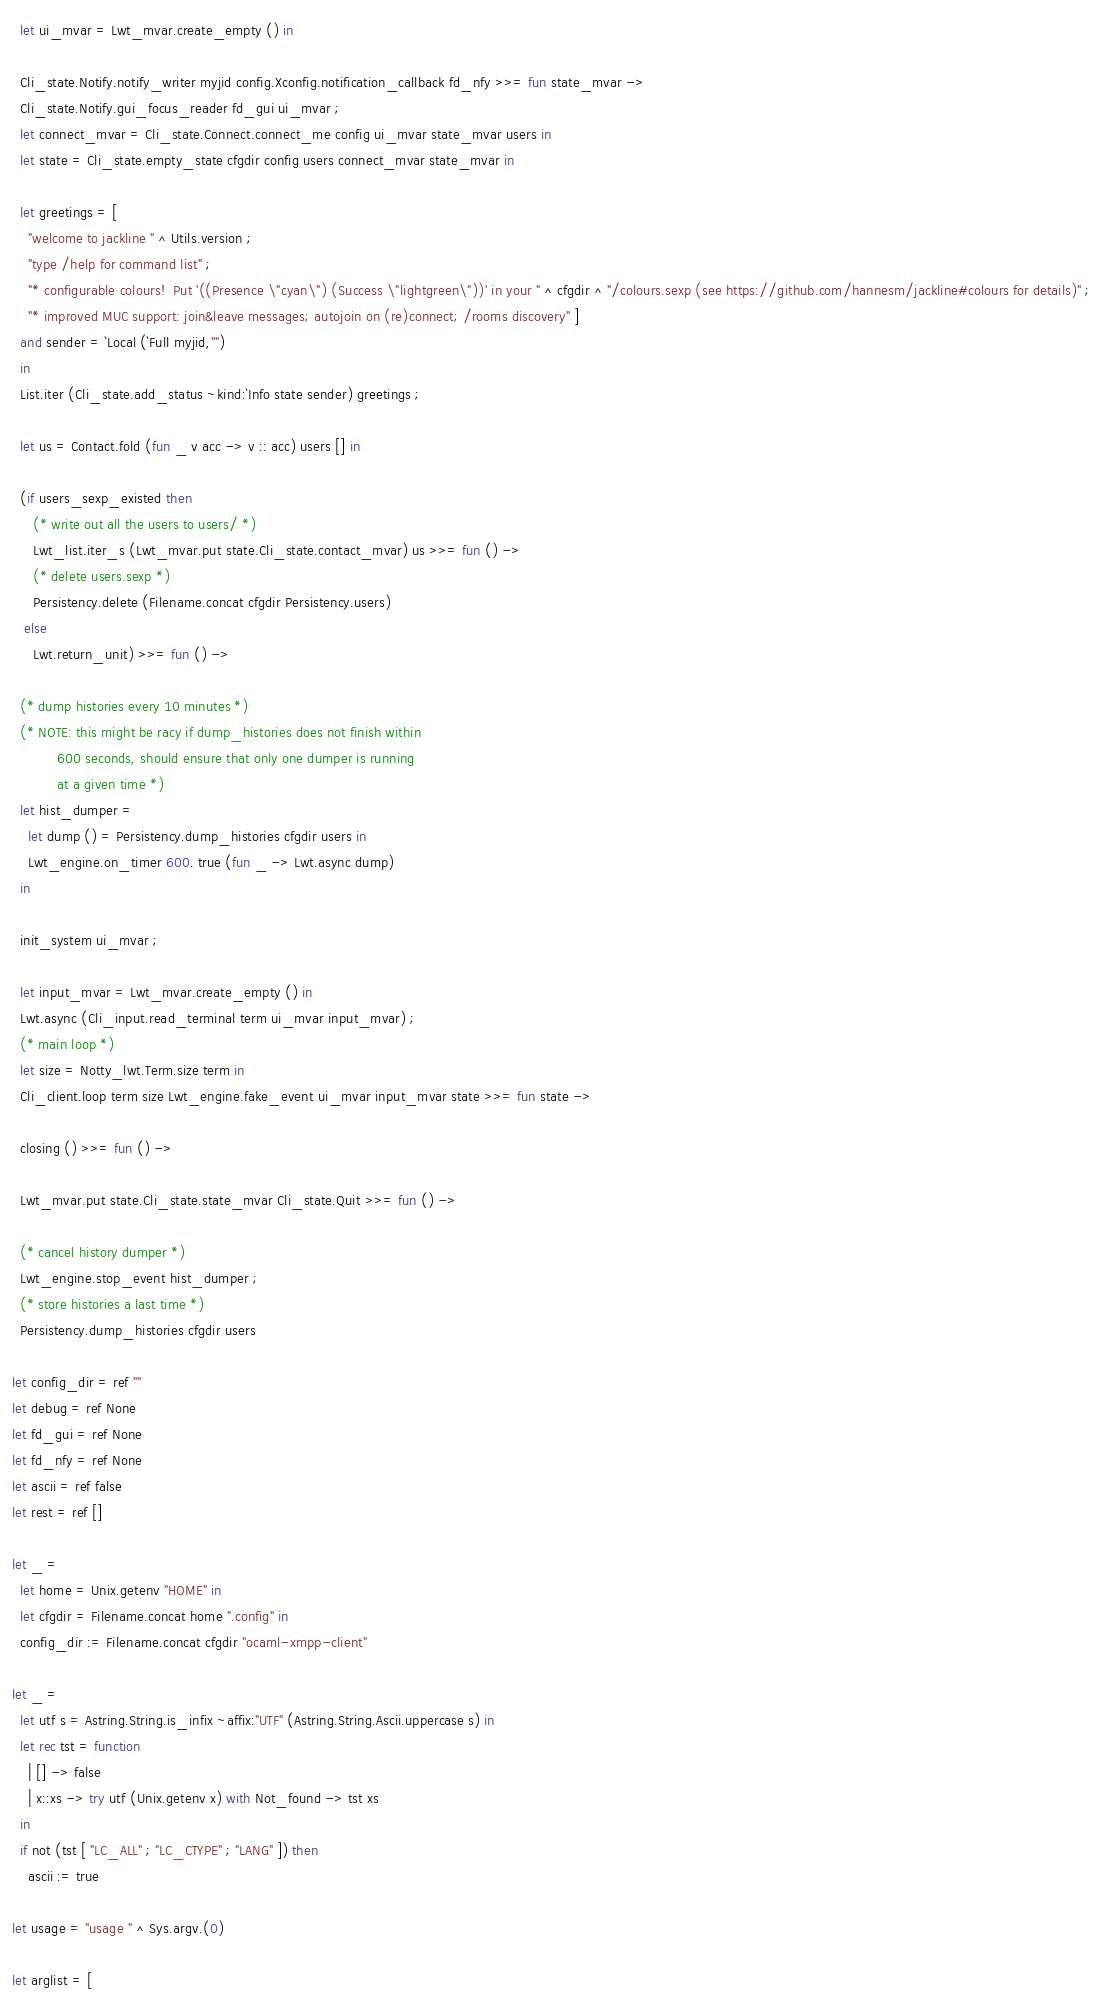<code> <loc_0><loc_0><loc_500><loc_500><_OCaml_>
  let ui_mvar = Lwt_mvar.create_empty () in

  Cli_state.Notify.notify_writer myjid config.Xconfig.notification_callback fd_nfy >>= fun state_mvar ->
  Cli_state.Notify.gui_focus_reader fd_gui ui_mvar ;
  let connect_mvar = Cli_state.Connect.connect_me config ui_mvar state_mvar users in
  let state = Cli_state.empty_state cfgdir config users connect_mvar state_mvar in

  let greetings = [
    "welcome to jackline " ^ Utils.version ;
    "type /help for command list" ;
    "* configurable colours!  Put '((Presence \"cyan\") (Success \"lightgreen\"))' in your " ^ cfgdir ^ "/colours.sexp (see https://github.com/hannesm/jackline#colours for details)" ;
    "* improved MUC support: join&leave messages; autojoin on (re)connect; /rooms discovery" ]
  and sender = `Local (`Full myjid,"")
  in
  List.iter (Cli_state.add_status ~kind:`Info state sender) greetings ;

  let us = Contact.fold (fun _ v acc -> v :: acc) users [] in

  (if users_sexp_existed then
     (* write out all the users to users/ *)
     Lwt_list.iter_s (Lwt_mvar.put state.Cli_state.contact_mvar) us >>= fun () ->
     (* delete users.sexp *)
     Persistency.delete (Filename.concat cfgdir Persistency.users)
   else
     Lwt.return_unit) >>= fun () ->

  (* dump histories every 10 minutes *)
  (* NOTE: this might be racy if dump_histories does not finish within
           600 seconds, should ensure that only one dumper is running
           at a given time *)
  let hist_dumper =
    let dump () = Persistency.dump_histories cfgdir users in
    Lwt_engine.on_timer 600. true (fun _ -> Lwt.async dump)
  in

  init_system ui_mvar ;

  let input_mvar = Lwt_mvar.create_empty () in
  Lwt.async (Cli_input.read_terminal term ui_mvar input_mvar) ;
  (* main loop *)
  let size = Notty_lwt.Term.size term in
  Cli_client.loop term size Lwt_engine.fake_event ui_mvar input_mvar state >>= fun state ->

  closing () >>= fun () ->

  Lwt_mvar.put state.Cli_state.state_mvar Cli_state.Quit >>= fun () ->

  (* cancel history dumper *)
  Lwt_engine.stop_event hist_dumper ;
  (* store histories a last time *)
  Persistency.dump_histories cfgdir users

let config_dir = ref ""
let debug = ref None
let fd_gui = ref None
let fd_nfy = ref None
let ascii = ref false
let rest = ref []

let _ =
  let home = Unix.getenv "HOME" in
  let cfgdir = Filename.concat home ".config" in
  config_dir := Filename.concat cfgdir "ocaml-xmpp-client"

let _ =
  let utf s = Astring.String.is_infix ~affix:"UTF" (Astring.String.Ascii.uppercase s) in
  let rec tst = function
    | [] -> false
    | x::xs -> try utf (Unix.getenv x) with Not_found -> tst xs
  in
  if not (tst [ "LC_ALL" ; "LC_CTYPE" ; "LANG" ]) then
    ascii := true

let usage = "usage " ^ Sys.argv.(0)

let arglist = [</code> 